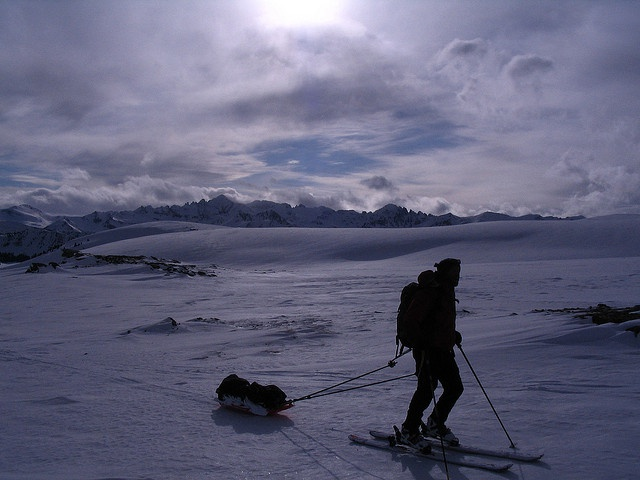Describe the objects in this image and their specific colors. I can see people in gray and black tones, skis in gray, black, purple, and navy tones, backpack in gray and black tones, and backpack in gray and black tones in this image. 